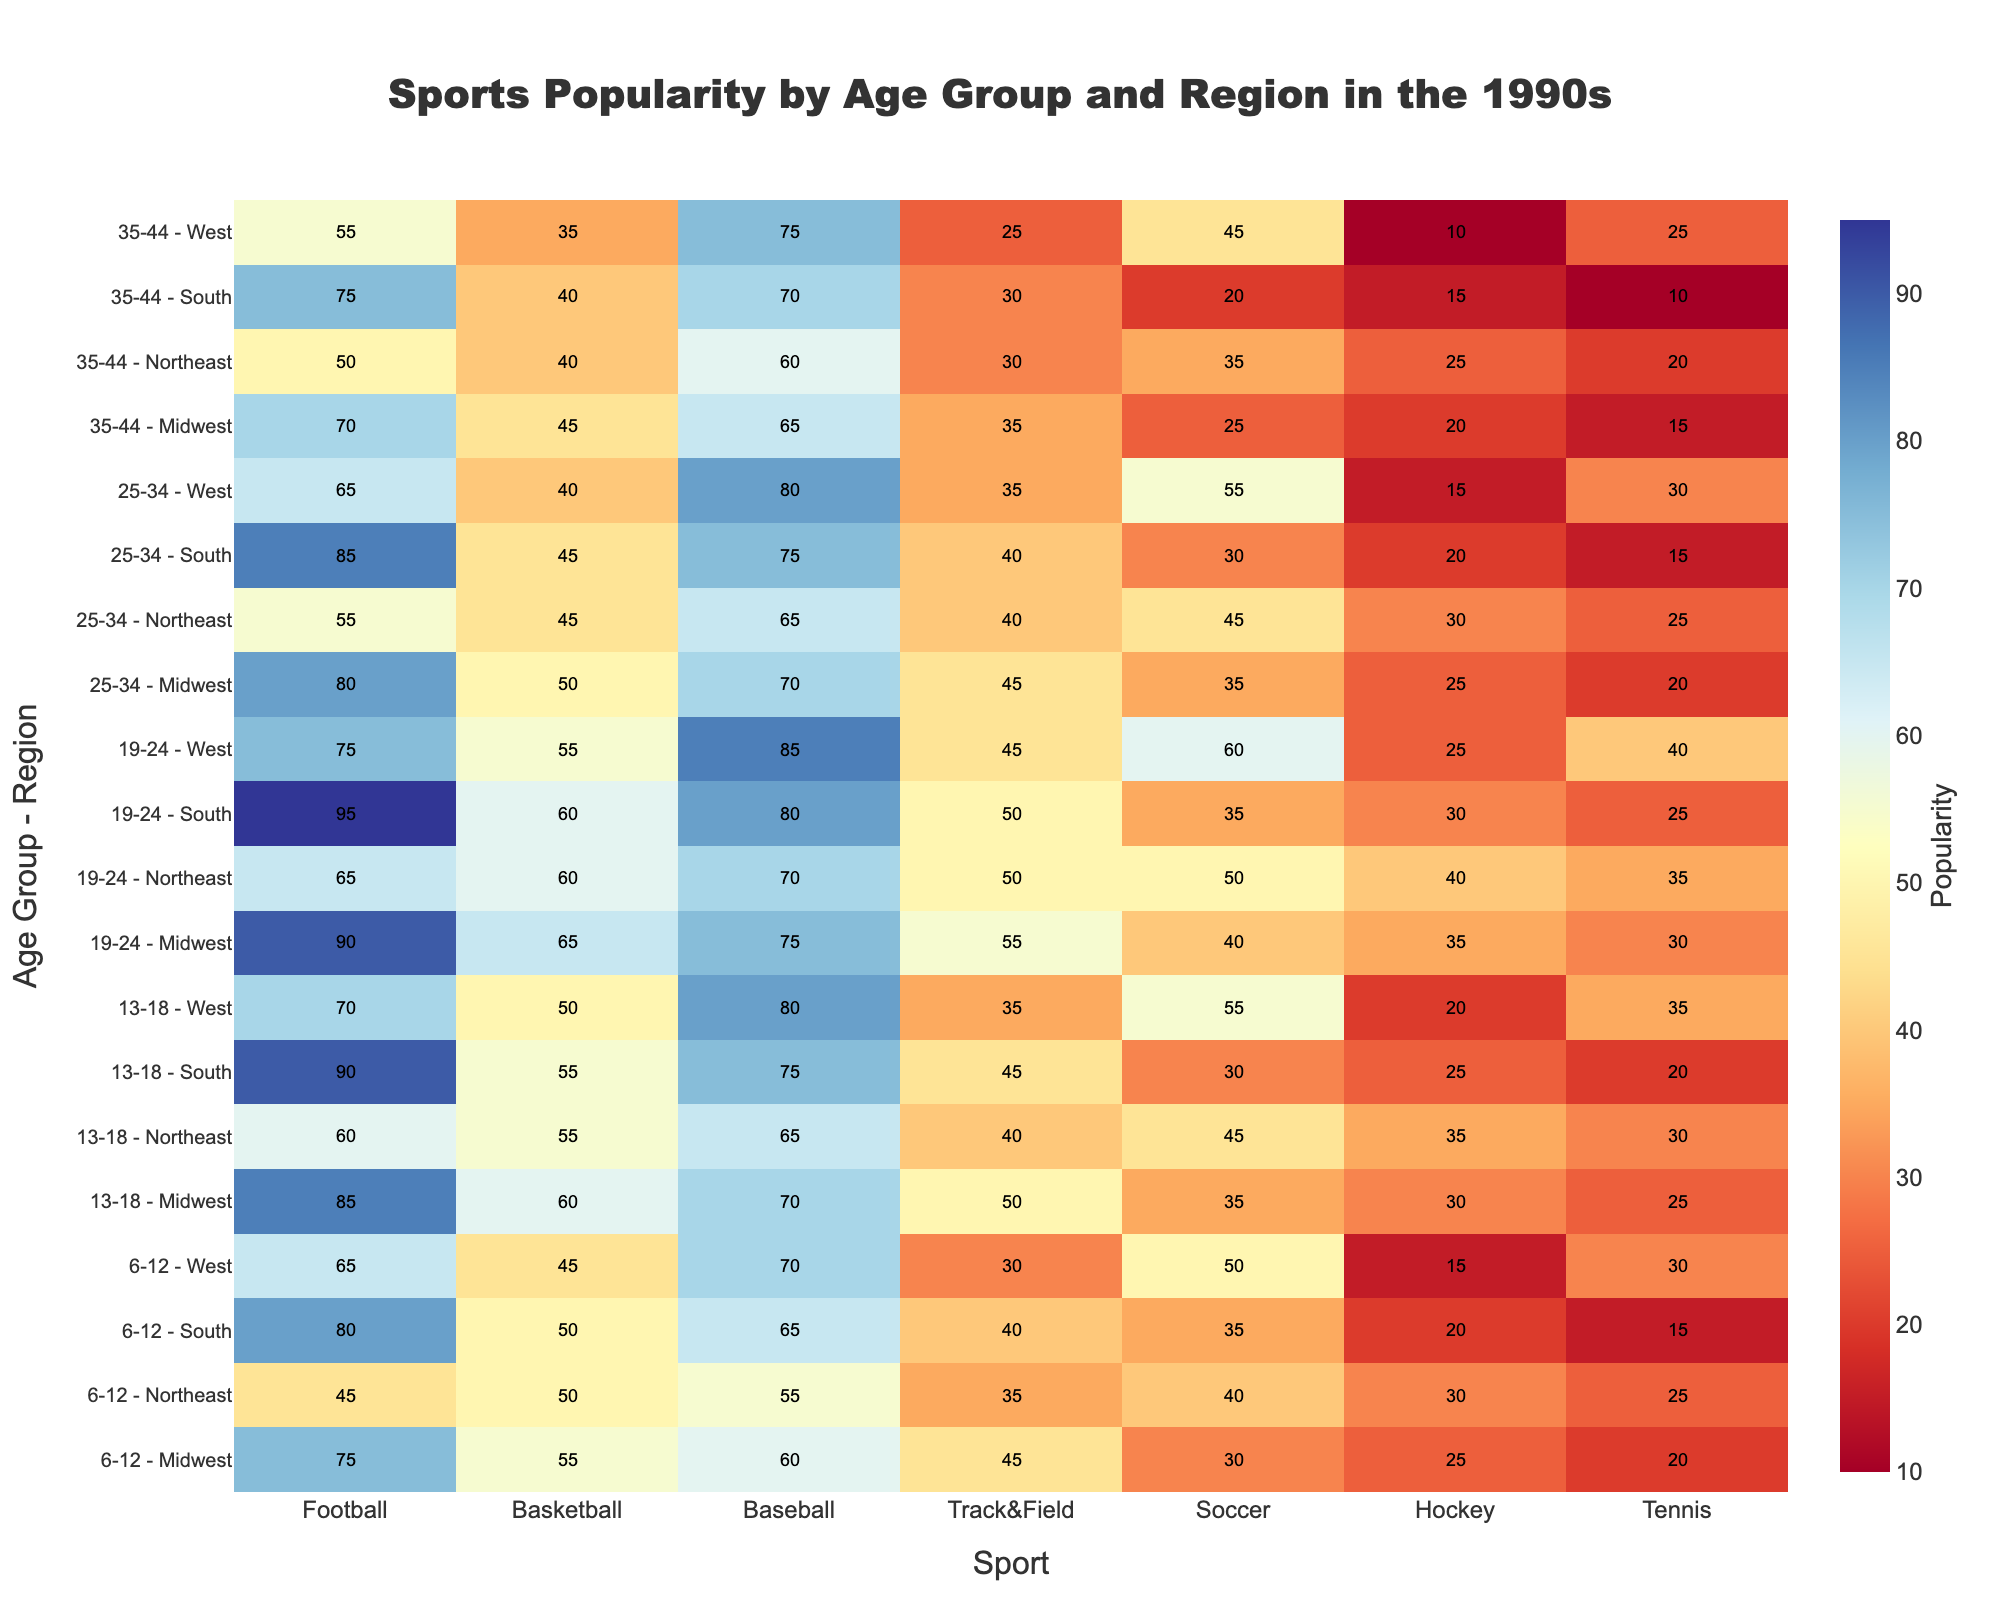What is the popularity score of Tennis among the 19-24 age group in the Northeast? Locate the row labeled "19-24 - Northeast" on the y-axis and the column labeled "Tennis" on the x-axis. The intersection value is the popularity score.
Answer: 35 Which region has the highest popularity for Football in the 13-18 age group? Check the values in the Football column for the 13-18 age group in all regions. Compare and see the highest value.
Answer: South How does the popularity of Soccer compare between the West region and the Midwest region for the 25-34 age group? Locate the popularity scores for Soccer in the 25-34 age group for both the West and Midwest regions and compare them. Midwest has a score of 35 and West has 55.
Answer: West is higher What is the overall trend in the popularity of Baseball as people age from 6-12 to 35-44 in the Midwest? Track the popularity scores in the Baseball column for the Midwest from the 6-12 age group to the 35-44 age group.
Answer: Decreasing How does the popularity of Track & Field change from the Northeast region in the 6-12 age group to the South region in the 19-24 age group? Identify the Track & Field popularity scores in "6-12 - Northeast" and "19-24 - South". Compare them directly.
Answer: Increase (from 35 to 50) In which age group and region is Hockey the least popular? Check all the values in the Hockey column across all age groups and regions. Find the minimum value, which is 10, and identify its corresponding age group and region.
Answer: 35-44, West If you sum the popularity scores of Soccer and Basketball for the 19-24 age group in the West, what is the total? Find the popularity scores of Soccer and Basketball in the "19-24 - West" row; Soccer is 60 and Basketball is 55. Sum these values.
Answer: 115 Which sport has the lowest popularity in the 6-12 age group across all regions? Check all the sports' popularity in the 6-12 age group for each region and identify the minimum value, which is in the Hockey column for the West with a score of 15.
Answer: Hockey 